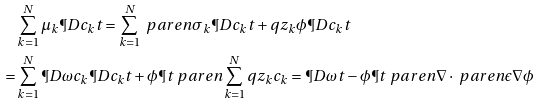<formula> <loc_0><loc_0><loc_500><loc_500>& \sum _ { k = 1 } ^ { N } \mu _ { k } \P D { c _ { k } } { t } = \sum _ { k = 1 } ^ { N } \ p a r e n { \sigma _ { k } \P D { c _ { k } } { t } + q z _ { k } \phi \P D { c _ { k } } { t } } \\ = & \sum _ { k = 1 } ^ { N } \P D { \omega } { c _ { k } } \P D { c _ { k } } { t } + \phi \P { t } \ p a r e n { \sum _ { k = 1 } ^ { N } q z _ { k } c _ { k } } = \P D { \omega } { t } - \phi \P { t } \ p a r e n { \nabla \cdot \ p a r e n { \epsilon \nabla \phi } }</formula> 